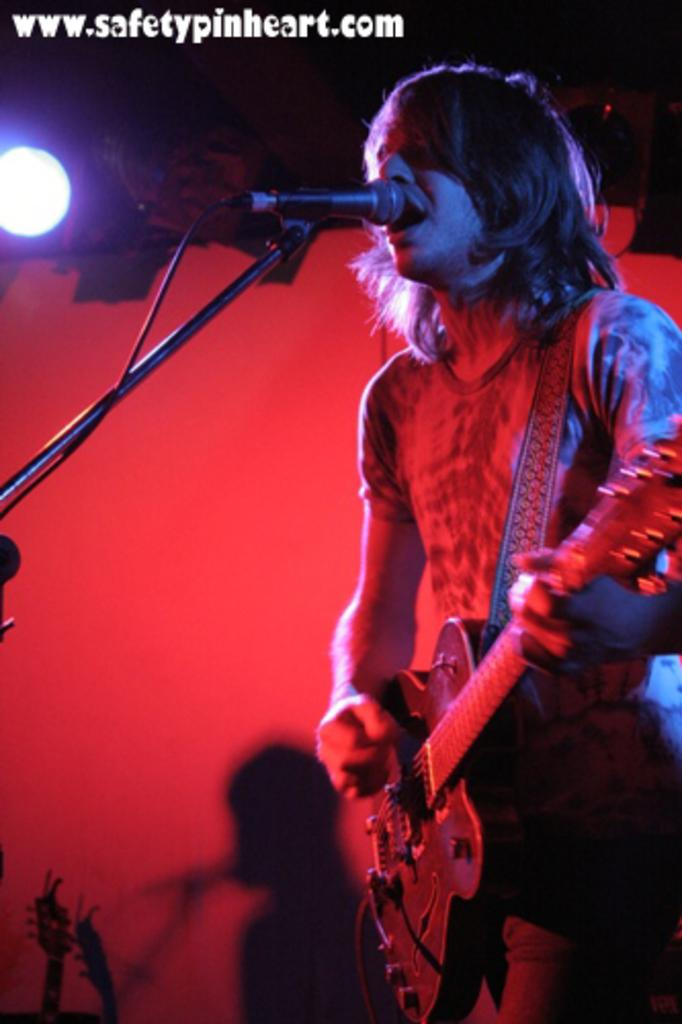What is the man in the image doing? The man is holding a guitar and singing. What object is the man holding in the image? The man is holding a guitar. What can be seen in the background of the image? There is a microphone and a light in the background. What type of dress is the man wearing in the image? The man is not wearing a dress in the image; he is wearing clothing appropriate for playing the guitar and singing. 